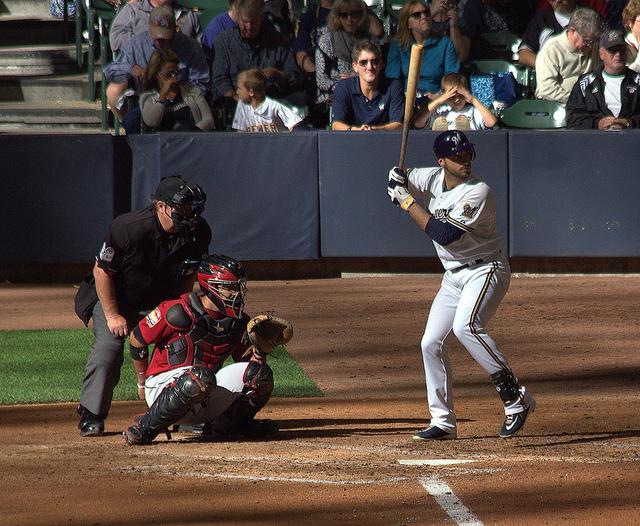Are they playing soccer?
Answer briefly. No. Are the people in the crowd standing?
Write a very short answer. No. Are all the seats in the stands full?
Answer briefly. No. Does the batter have both feet flat on the ground?
Write a very short answer. No. What sport is this?
Keep it brief. Baseball. 